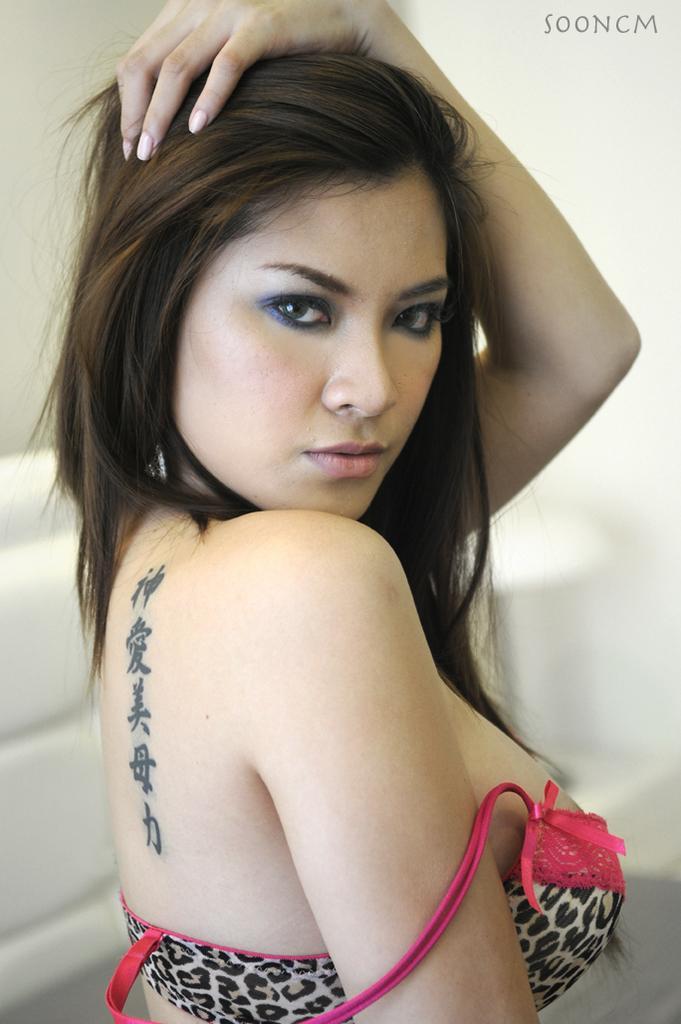How would you summarize this image in a sentence or two? In this picture we can see a woman. There is a white background. At the top right side of the image we can see a watermark. 